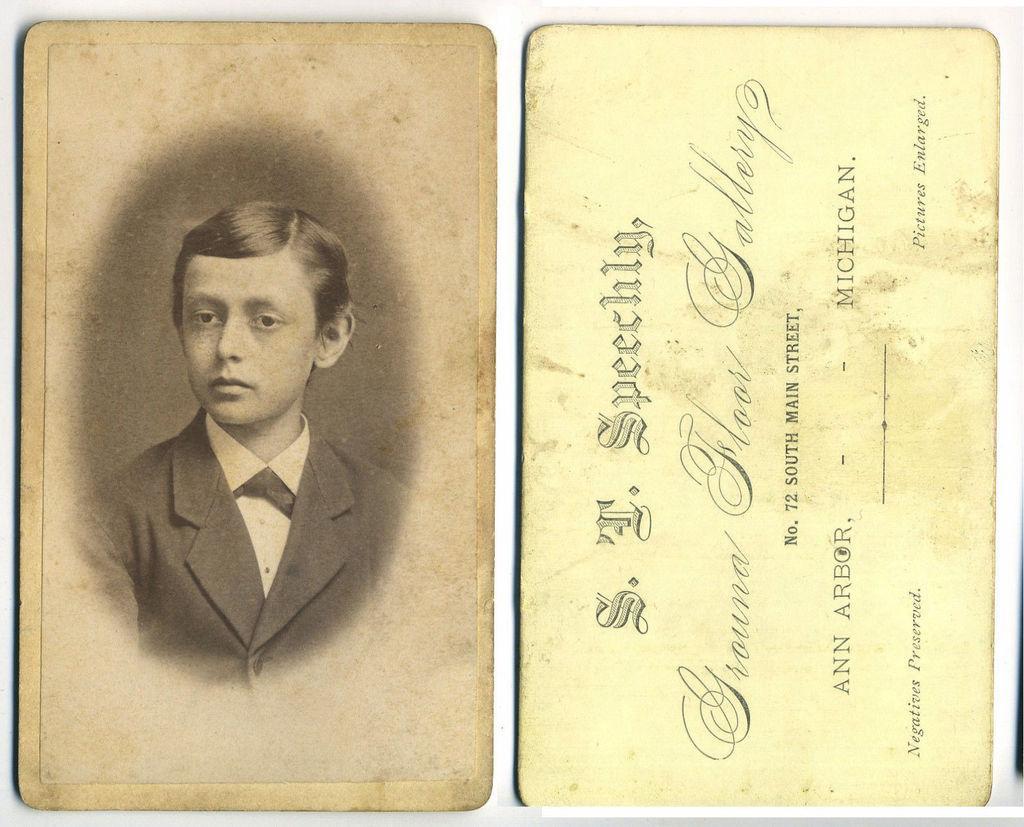Could you give a brief overview of what you see in this image? In this image, we can see cards contains depiction of a person and some text. 